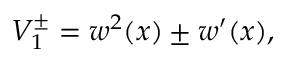<formula> <loc_0><loc_0><loc_500><loc_500>V _ { 1 } ^ { \pm } = w ^ { 2 } ( x ) \pm w ^ { \prime } ( x ) ,</formula> 